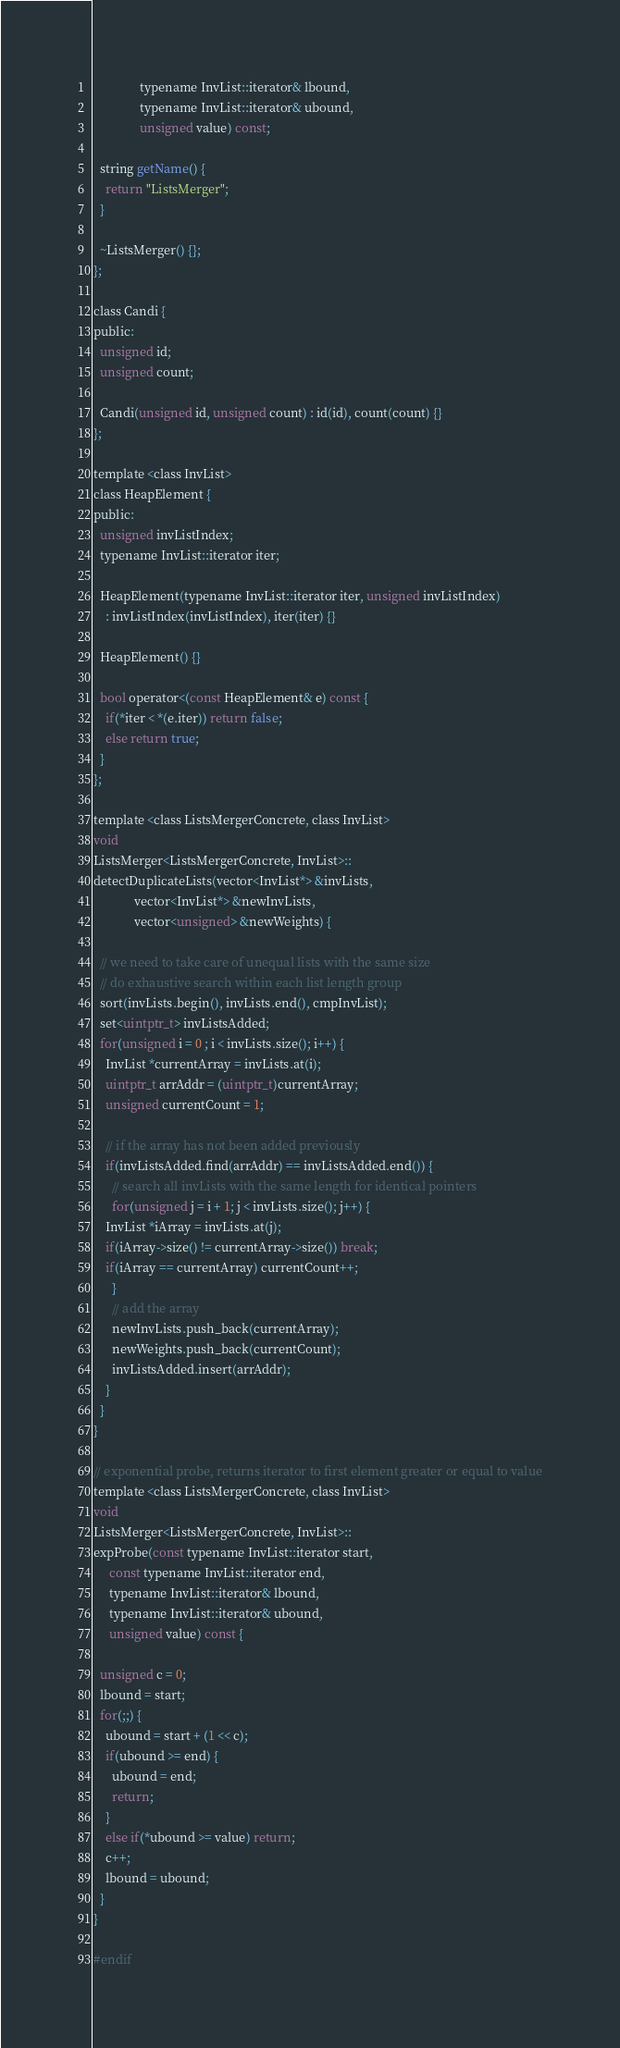Convert code to text. <code><loc_0><loc_0><loc_500><loc_500><_C_>		       typename InvList::iterator& lbound,
		       typename InvList::iterator& ubound,
		       unsigned value) const;

  string getName() {
    return "ListsMerger";
  }

  ~ListsMerger() {};
};

class Candi {
public:
  unsigned id;
  unsigned count;

  Candi(unsigned id, unsigned count) : id(id), count(count) {}
};

template <class InvList>
class HeapElement {
public:
  unsigned invListIndex;
  typename InvList::iterator iter;

  HeapElement(typename InvList::iterator iter, unsigned invListIndex)
    : invListIndex(invListIndex), iter(iter) {}

  HeapElement() {}

  bool operator<(const HeapElement& e) const {
    if(*iter < *(e.iter)) return false;
    else return true;
  }
};

template <class ListsMergerConcrete, class InvList>
void
ListsMerger<ListsMergerConcrete, InvList>::
detectDuplicateLists(vector<InvList*> &invLists,
		     vector<InvList*> &newInvLists,
		     vector<unsigned> &newWeights) {

  // we need to take care of unequal lists with the same size
  // do exhaustive search within each list length group
  sort(invLists.begin(), invLists.end(), cmpInvList);
  set<uintptr_t> invListsAdded;
  for(unsigned i = 0 ; i < invLists.size(); i++) {
    InvList *currentArray = invLists.at(i);
    uintptr_t arrAddr = (uintptr_t)currentArray;
    unsigned currentCount = 1;

    // if the array has not been added previously
    if(invListsAdded.find(arrAddr) == invListsAdded.end()) {
      // search all invLists with the same length for identical pointers
      for(unsigned j = i + 1; j < invLists.size(); j++) {
	InvList *iArray = invLists.at(j);
	if(iArray->size() != currentArray->size()) break;
	if(iArray == currentArray) currentCount++;
      }
      // add the array
      newInvLists.push_back(currentArray);
      newWeights.push_back(currentCount);
      invListsAdded.insert(arrAddr);
    }
  }
}

// exponential probe, returns iterator to first element greater or equal to value
template <class ListsMergerConcrete, class InvList>
void
ListsMerger<ListsMergerConcrete, InvList>::
expProbe(const typename InvList::iterator start,
	 const typename InvList::iterator end,
	 typename InvList::iterator& lbound,
	 typename InvList::iterator& ubound,
	 unsigned value) const {

  unsigned c = 0;
  lbound = start;
  for(;;) {
    ubound = start + (1 << c);
    if(ubound >= end) {
      ubound = end;
      return;
    }
    else if(*ubound >= value) return;
    c++;
    lbound = ubound;
  }
}

#endif
</code> 